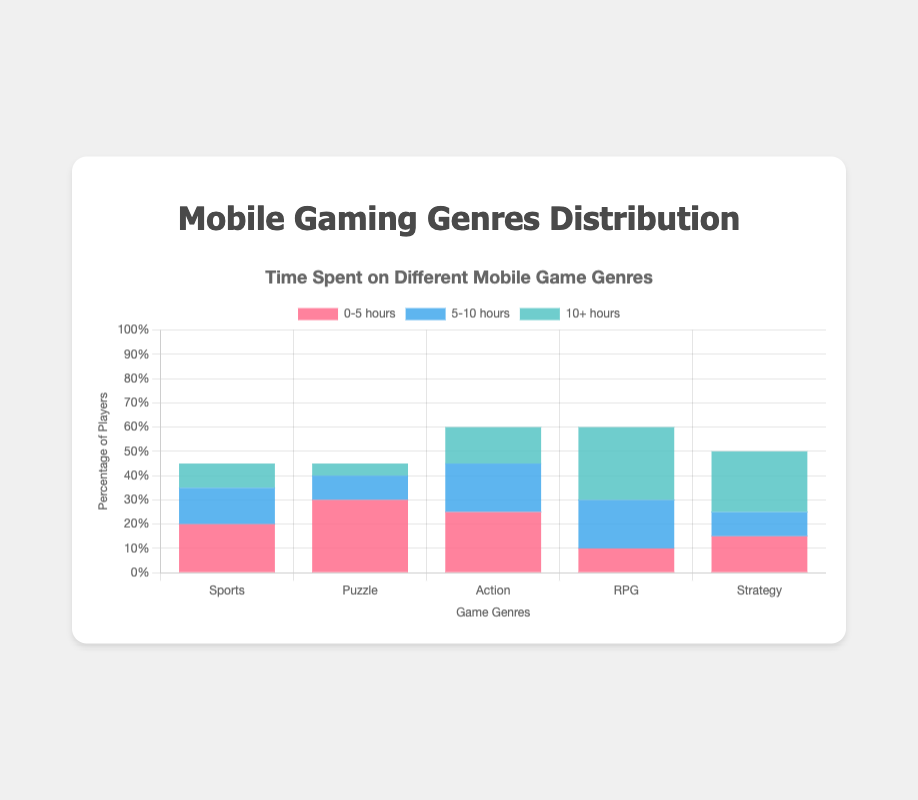Which game genre has the highest percentage of players in the '0-5 hours' category? Look at the bars labeled '0-5 hours' for each genre. The highest bar represents the genre with the highest percentage of players in this category.
Answer: Puzzle Which game genre has the lowest percentage of players in the '10+ hours' category? Look at the bars labeled '10+ hours' for each genre. The lowest bar represents the genre with the lowest percentage of players in this category.
Answer: Puzzle How much more time do players spend on RPG games compared to Sports games in the '10+ hours' category? Subtract the height of the '10+ hours' bar for Sports from the height of the '10+ hours' bar for RPG. RPG has 30%, Sports has 10%, so 30 - 10 = 20%.
Answer: 20% Which genre has the closest percentage of players in the '5-10 hours' category to the percentage in '0-5 hours'? Compare the bars labeled '5-10 hours' and '0-5 hours' for each genre and find the one where the difference is smallest. For Sports, it's 15-20=5%. For Puzzle, it's 10-30=20%. For Action, it's 20-25=5%. For RPG, it's 20-10=-10%. For Strategy, it's 10-15=5%. RPG has the smallest difference.
Answer: RPG Which genre shows the largest increase in the percentage of players from '5-10 hours' to '10+ hours'? Subtract the '5-10 hours' percentage from the '10+ hours' percentage for each genre. Calculate for each genre and identify the largest increase. RPG: 30-20=10%.
Answer: RPG What's the total percentage of players spending '10+ hours' on Action and Strategy games combined? Add the '10+ hours' bar lengths for Action and Strategy. Action has 15%, Strategy has 25%, so 15 + 25 = 40%.
Answer: 40% How much more popular are Sports games compared to Puzzle games for players who play '5-10 hours'? Subtract the height of the '5-10 hours' bar for Puzzle from the height of the '5-10 hours' bar for Sports. Sports has 15%, Puzzle has 10%, so 15 - 10 = 5%.
Answer: 5% What is the average percentage of players in the '0-5 hours' category across all genres? Sum the '0-5 hours' values and divide by the number of genres. (20+30+25+10+15)/5 = 100/5 = 20%.
Answer: 20% In which category do Strategy games have the highest percentage of players? Compare the three bars for Strategy games and identify which one is the tallest. The '10+ hours' category has 25%.
Answer: '10+ hours' What is the difference in percentage of players between Action and Strategy games in the '0-5 hours' category? Subtract the percentage for Strategy (15%) from the percentage for Action (25%). 25 - 15 = 10%.
Answer: 10% 